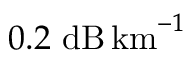Convert formula to latex. <formula><loc_0><loc_0><loc_500><loc_500>0 . 2 d B \, k m ^ { - 1 }</formula> 